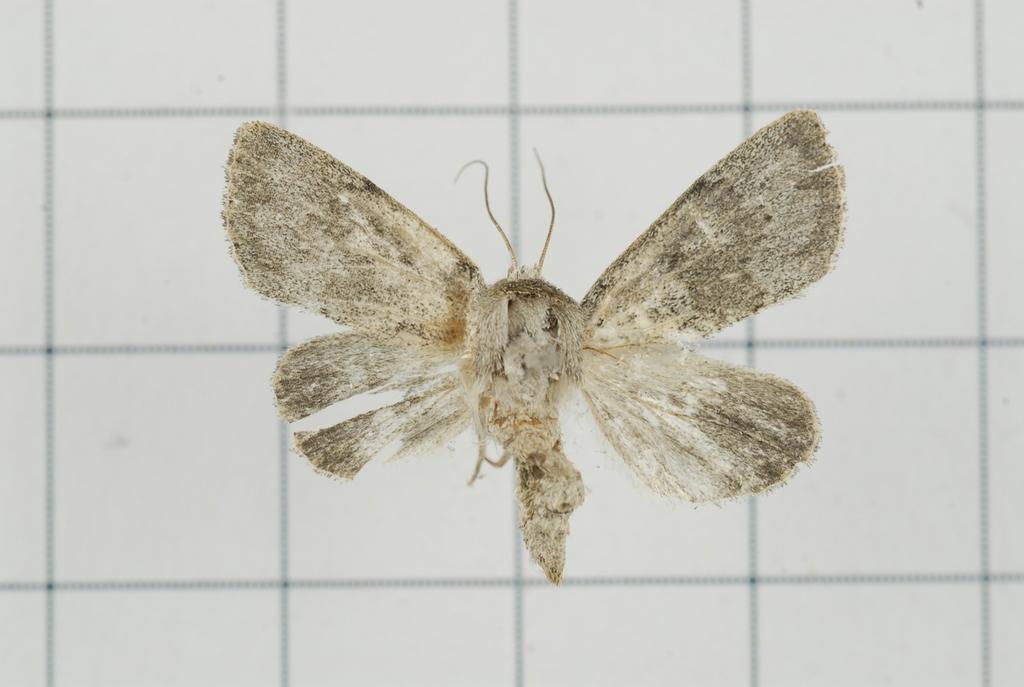In one or two sentences, can you explain what this image depicts? In the picture I can see an insect on the white color surface and here I can see black color lines on it. 